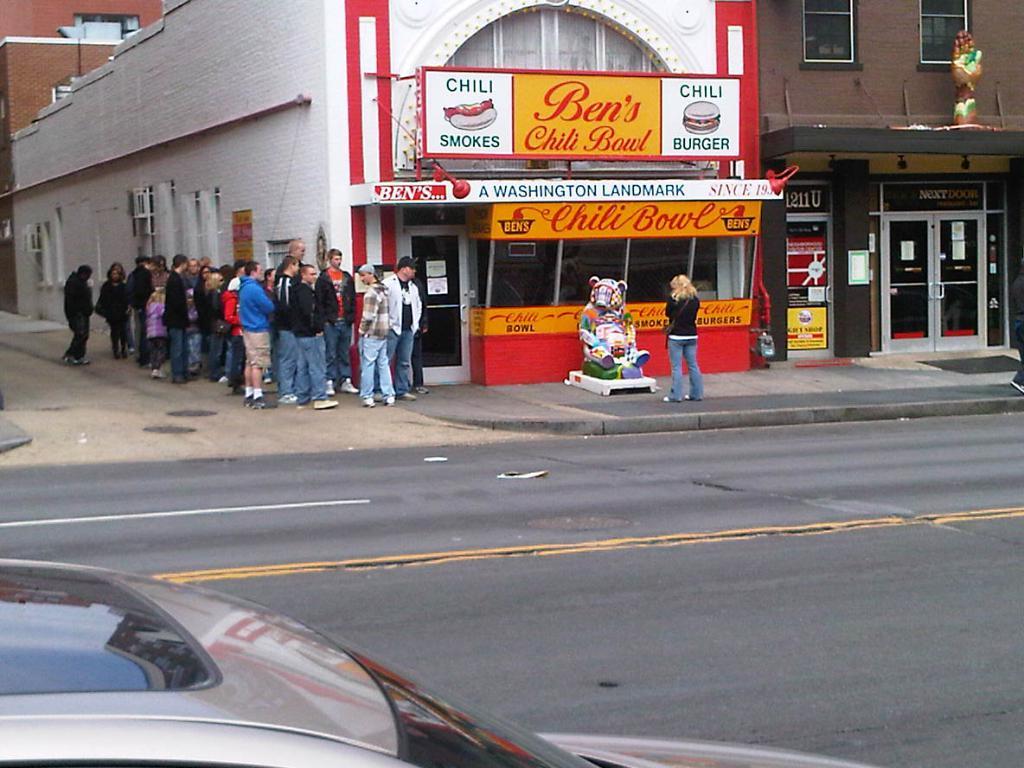What's the name of this restaurant?
Provide a succinct answer. Ben's chili bowl. What can you buy at the restaurant?
Provide a succinct answer. Chili. 